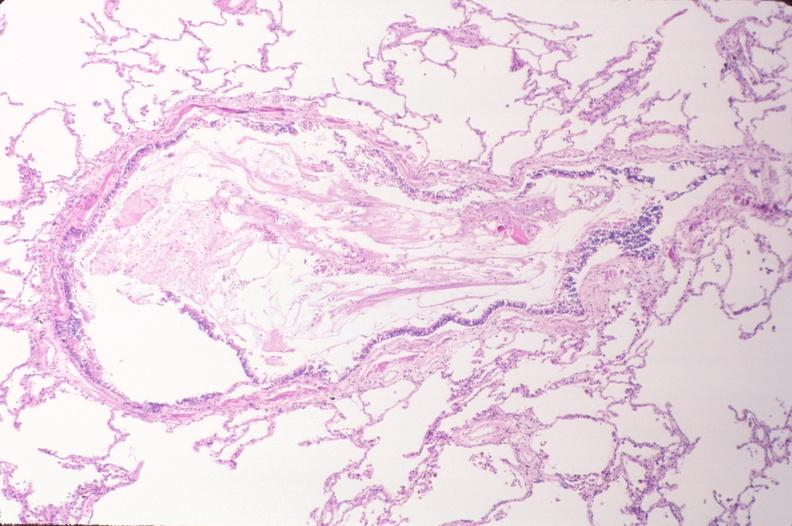s respiratory present?
Answer the question using a single word or phrase. Yes 